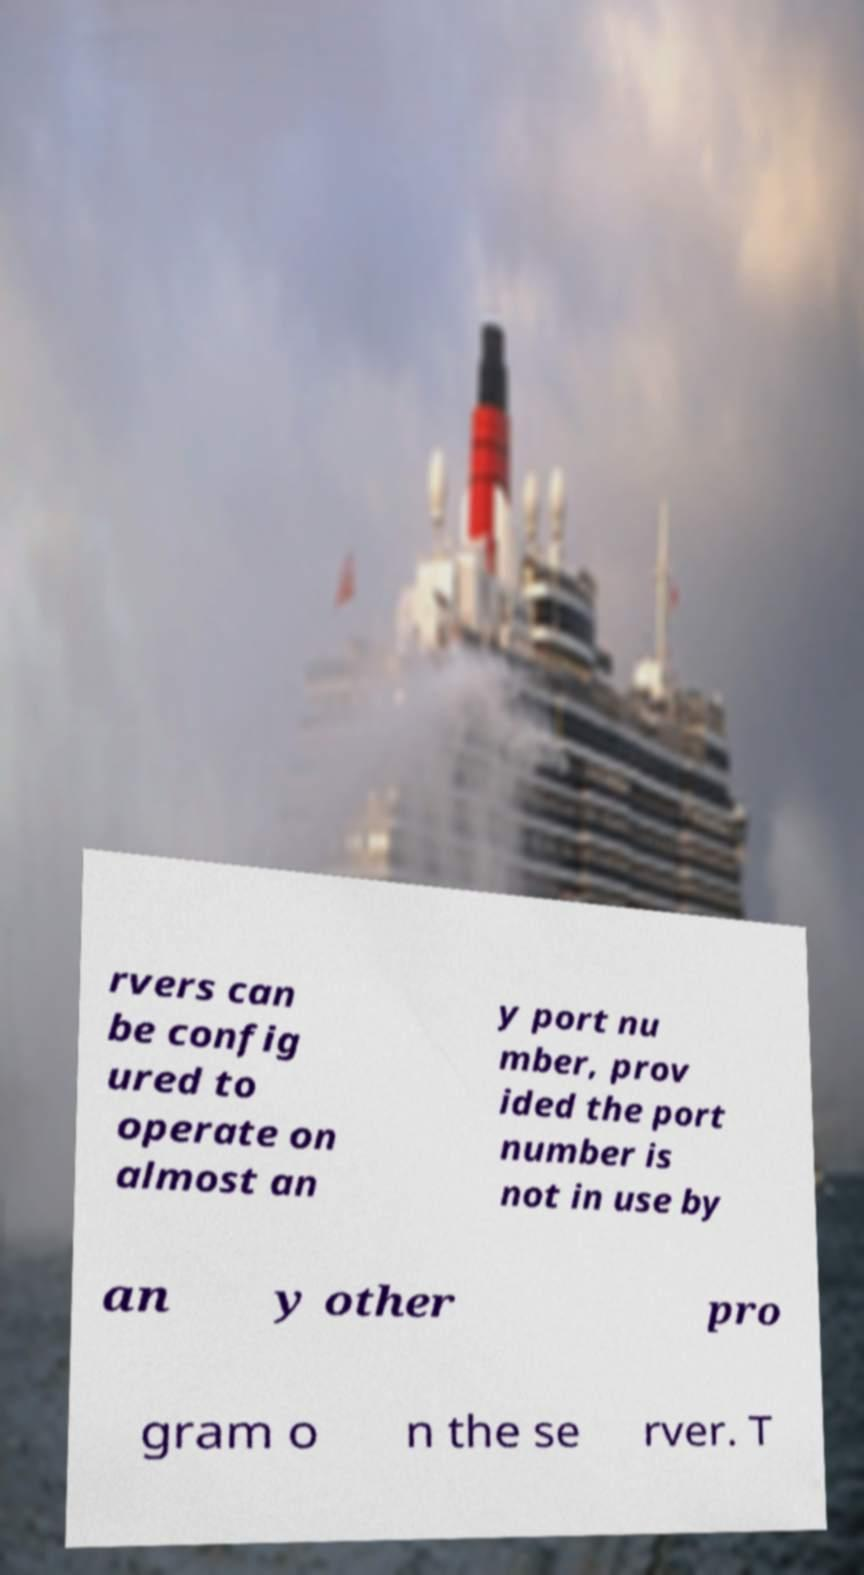There's text embedded in this image that I need extracted. Can you transcribe it verbatim? rvers can be config ured to operate on almost an y port nu mber, prov ided the port number is not in use by an y other pro gram o n the se rver. T 